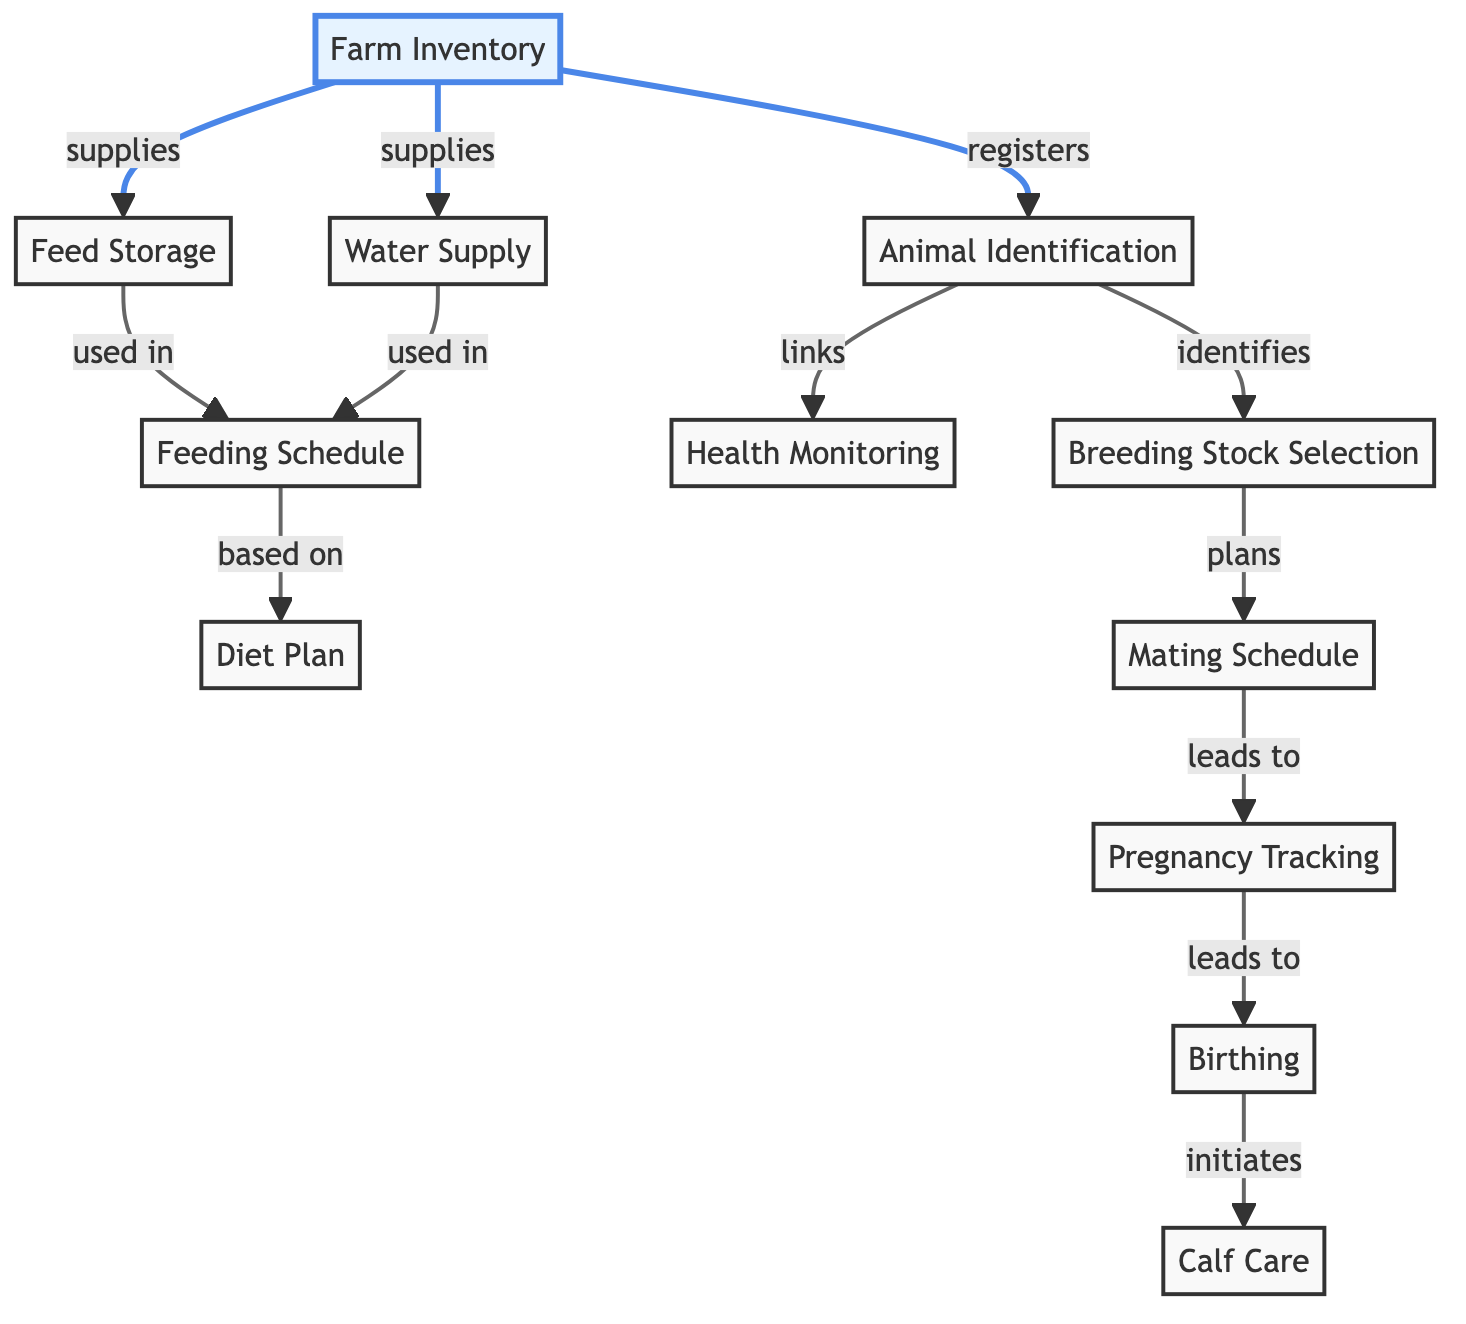What are the main components of livestock management depicted in the diagram? The diagram consists of several nodes representing key components of livestock management, including Farm Inventory, Feed Storage, Water Supply, and others concerned with feeding and breeding.
Answer: Farm Inventory, Feed Storage, Water Supply, Animal Identification, Health Monitoring, Feeding Schedule, Diet Plan, Breeding Stock Selection, Mating Schedule, Pregnancy Tracking, Birthing, Calf Care How many edges are there in the diagram? An edge represents a connection between two nodes, and by counting the connections shown, there are a total of 12 edges connecting various nodes in the diagram.
Answer: 12 What is the relationship between "Animal Identification" and "Health Monitoring"? The edge connecting these nodes indicates that Animal Identification links to Health Monitoring, meaning the identification of animals is related to their health monitoring.
Answer: links Which node is responsible for determining the feeding schedule? The Feeding Schedule node is derived from both Feed Storage and Water Supply; it is used in conjunction with these nodes to determine how and when animals are fed.
Answer: Feeding Schedule What does "Pregnancy Tracking" lead to in the process? From the diagram, Pregnancy Tracking leads to the next step, which is Birthing, indicating it is an important stage in livestock management.
Answer: Birthing What node is identified as the starting point for breeding planning? The Breeding Stock Selection node is where breeding planning begins, being identified through links from Animal Identification.
Answer: Breeding Stock Selection How many feeding-related nodes are there in the diagram? Upon review, there are three nodes directly related to feeding: Feed Storage, Feeding Schedule, and Diet Plan.
Answer: 3 What initiates Calf Care according to the graph? The node Birthing initiates Calf Care, indicating that after the birthing process, care for the calf begins.
Answer: Birthing Which node is used in creating the Diet Plan? The Diet Plan node is created based on the Feeding Schedule as indicated by the directed edge connecting the two nodes.
Answer: Feeding Schedule 